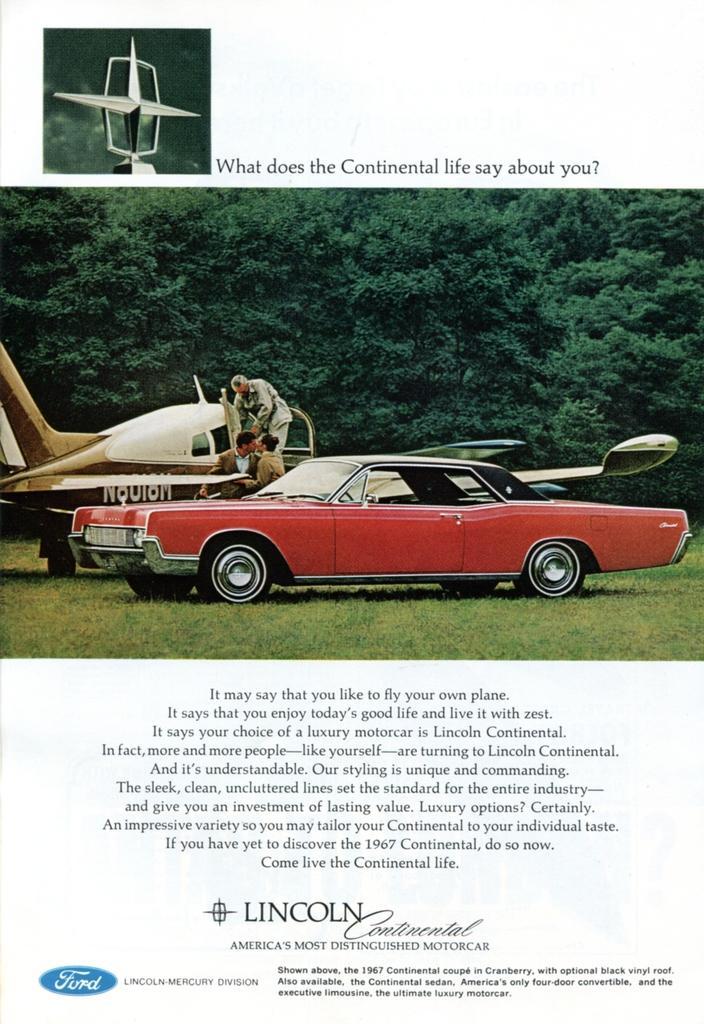In one or two sentences, can you explain what this image depicts? In the image we can see the poster, in the poster we can see vehicles, grass and trees, we can see there are even people wearing clothes and here we can see the text. 